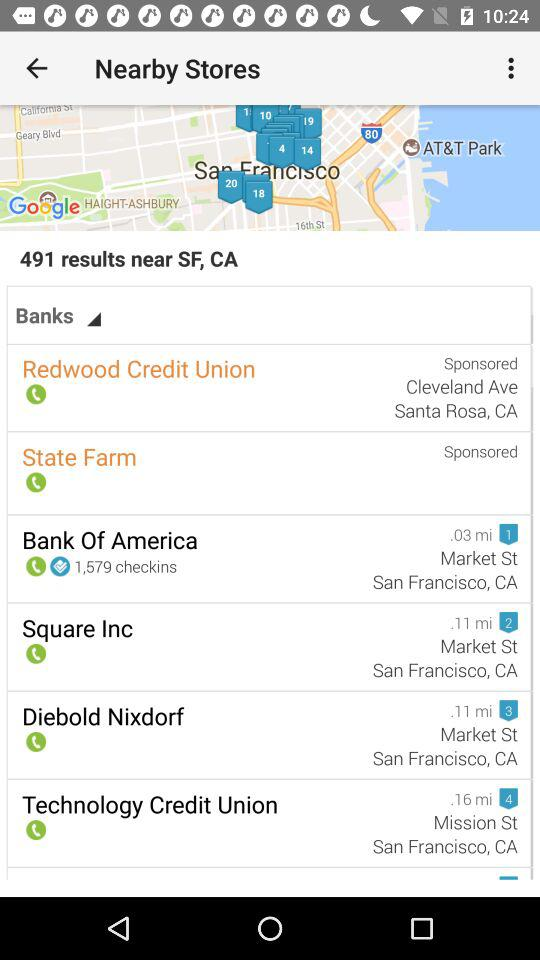How many results are shown for the search term Banks?
Answer the question using a single word or phrase. 491 